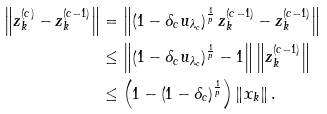<formula> <loc_0><loc_0><loc_500><loc_500>\left \| z _ { k } ^ { ( c ) } - z _ { k } ^ { ( c - 1 ) } \right \| & = \left \| \left ( 1 - \delta _ { c } u _ { \lambda _ { c } } \right ) ^ { \frac { 1 } { p } } z _ { k } ^ { ( c - 1 ) } - z _ { k } ^ { ( c - 1 ) } \right \| \\ & \leq \left \| \left ( 1 - \delta _ { c } u _ { \lambda _ { c } } \right ) ^ { \frac { 1 } { p } } - 1 \right \| \left \| z _ { k } ^ { ( c - 1 ) } \right \| \\ & \leq \left ( 1 - \left ( 1 - \delta _ { c } \right ) ^ { \frac { 1 } { p } } \right ) \left \| x _ { k } \right \| .</formula> 